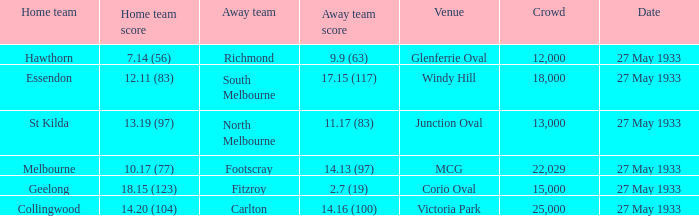During st kilda's home match, what was the quantity of individuals in the audience? 13000.0. 